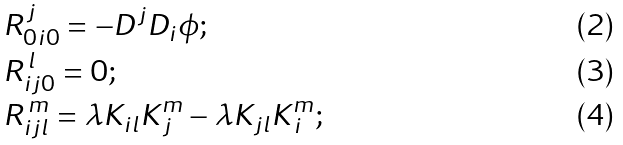<formula> <loc_0><loc_0><loc_500><loc_500>& R _ { 0 i 0 } ^ { \, j } = - D ^ { j } D _ { i } \phi ; \\ & R _ { i j 0 } ^ { \, l } = 0 ; \\ & R _ { i j l } ^ { \, m } = \lambda K _ { i l } K ^ { m } _ { \, j } - \lambda K _ { j l } K ^ { m } _ { \, i } ;</formula> 